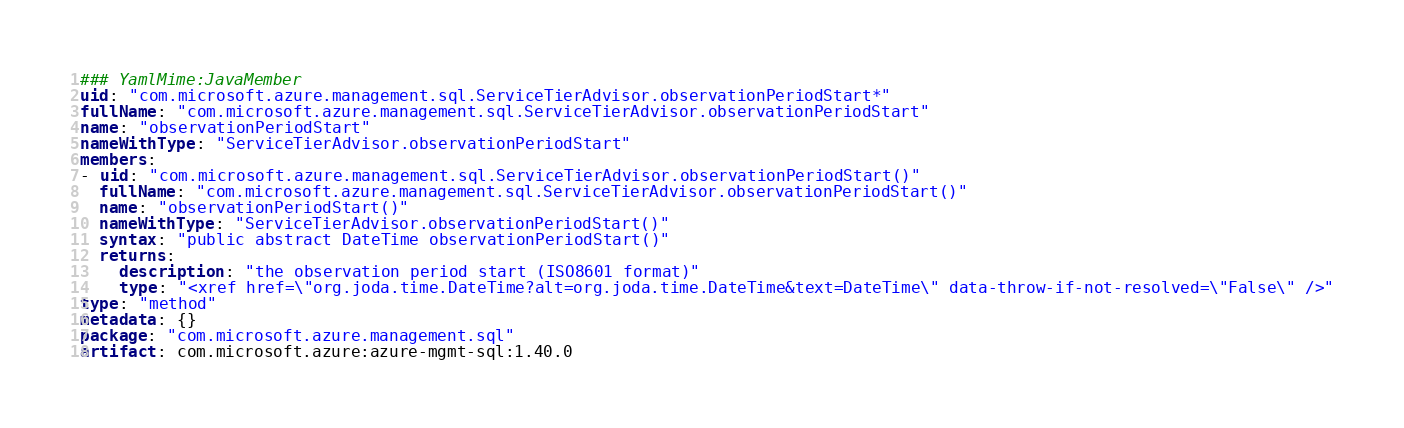<code> <loc_0><loc_0><loc_500><loc_500><_YAML_>### YamlMime:JavaMember
uid: "com.microsoft.azure.management.sql.ServiceTierAdvisor.observationPeriodStart*"
fullName: "com.microsoft.azure.management.sql.ServiceTierAdvisor.observationPeriodStart"
name: "observationPeriodStart"
nameWithType: "ServiceTierAdvisor.observationPeriodStart"
members:
- uid: "com.microsoft.azure.management.sql.ServiceTierAdvisor.observationPeriodStart()"
  fullName: "com.microsoft.azure.management.sql.ServiceTierAdvisor.observationPeriodStart()"
  name: "observationPeriodStart()"
  nameWithType: "ServiceTierAdvisor.observationPeriodStart()"
  syntax: "public abstract DateTime observationPeriodStart()"
  returns:
    description: "the observation period start (ISO8601 format)"
    type: "<xref href=\"org.joda.time.DateTime?alt=org.joda.time.DateTime&text=DateTime\" data-throw-if-not-resolved=\"False\" />"
type: "method"
metadata: {}
package: "com.microsoft.azure.management.sql"
artifact: com.microsoft.azure:azure-mgmt-sql:1.40.0
</code> 